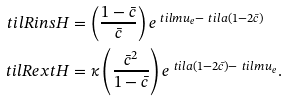Convert formula to latex. <formula><loc_0><loc_0><loc_500><loc_500>\ t i l R i n s H & = \left ( \frac { 1 - \bar { c } } { \bar { c } } \right ) e ^ { \ t i l m u _ { e } - \ t i l a ( 1 - 2 \bar { c } ) } \\ \ t i l R e x t H & = \kappa \left ( \frac { \bar { c } ^ { 2 } } { 1 - \bar { c } } \right ) e ^ { \ t i l a ( 1 - 2 \bar { c } ) - \ t i l m u _ { e } } .</formula> 